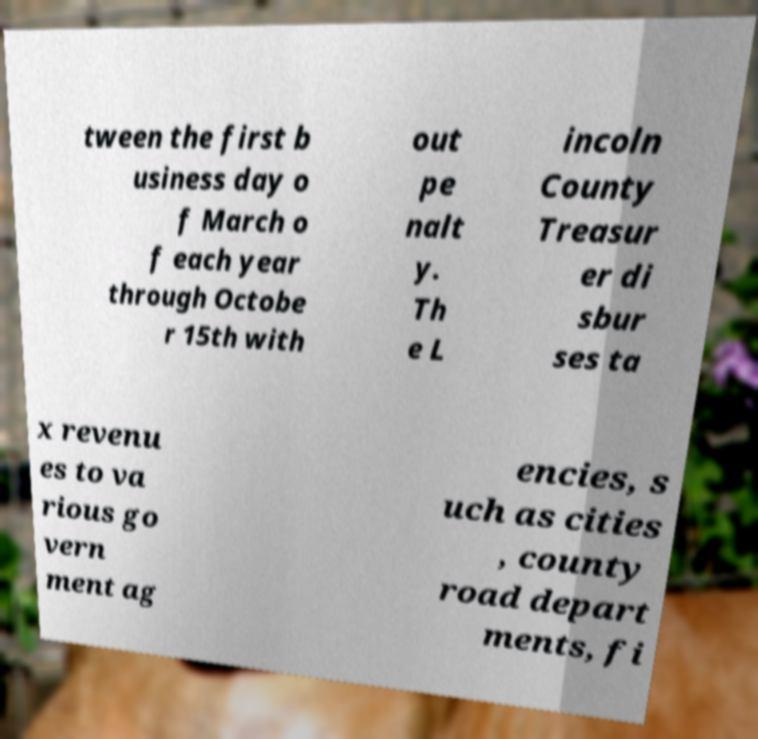For documentation purposes, I need the text within this image transcribed. Could you provide that? tween the first b usiness day o f March o f each year through Octobe r 15th with out pe nalt y. Th e L incoln County Treasur er di sbur ses ta x revenu es to va rious go vern ment ag encies, s uch as cities , county road depart ments, fi 